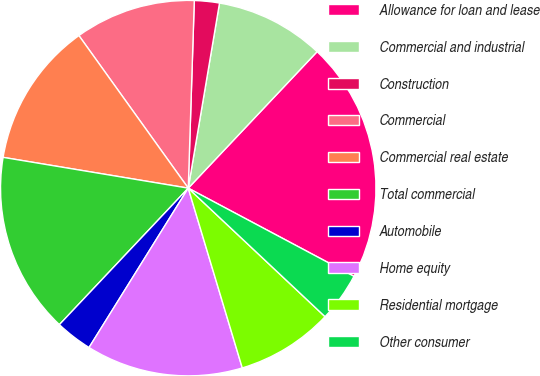Convert chart. <chart><loc_0><loc_0><loc_500><loc_500><pie_chart><fcel>Allowance for loan and lease<fcel>Commercial and industrial<fcel>Construction<fcel>Commercial<fcel>Commercial real estate<fcel>Total commercial<fcel>Automobile<fcel>Home equity<fcel>Residential mortgage<fcel>Other consumer<nl><fcel>20.74%<fcel>9.38%<fcel>2.15%<fcel>10.41%<fcel>12.48%<fcel>15.58%<fcel>3.18%<fcel>13.51%<fcel>8.35%<fcel>4.22%<nl></chart> 